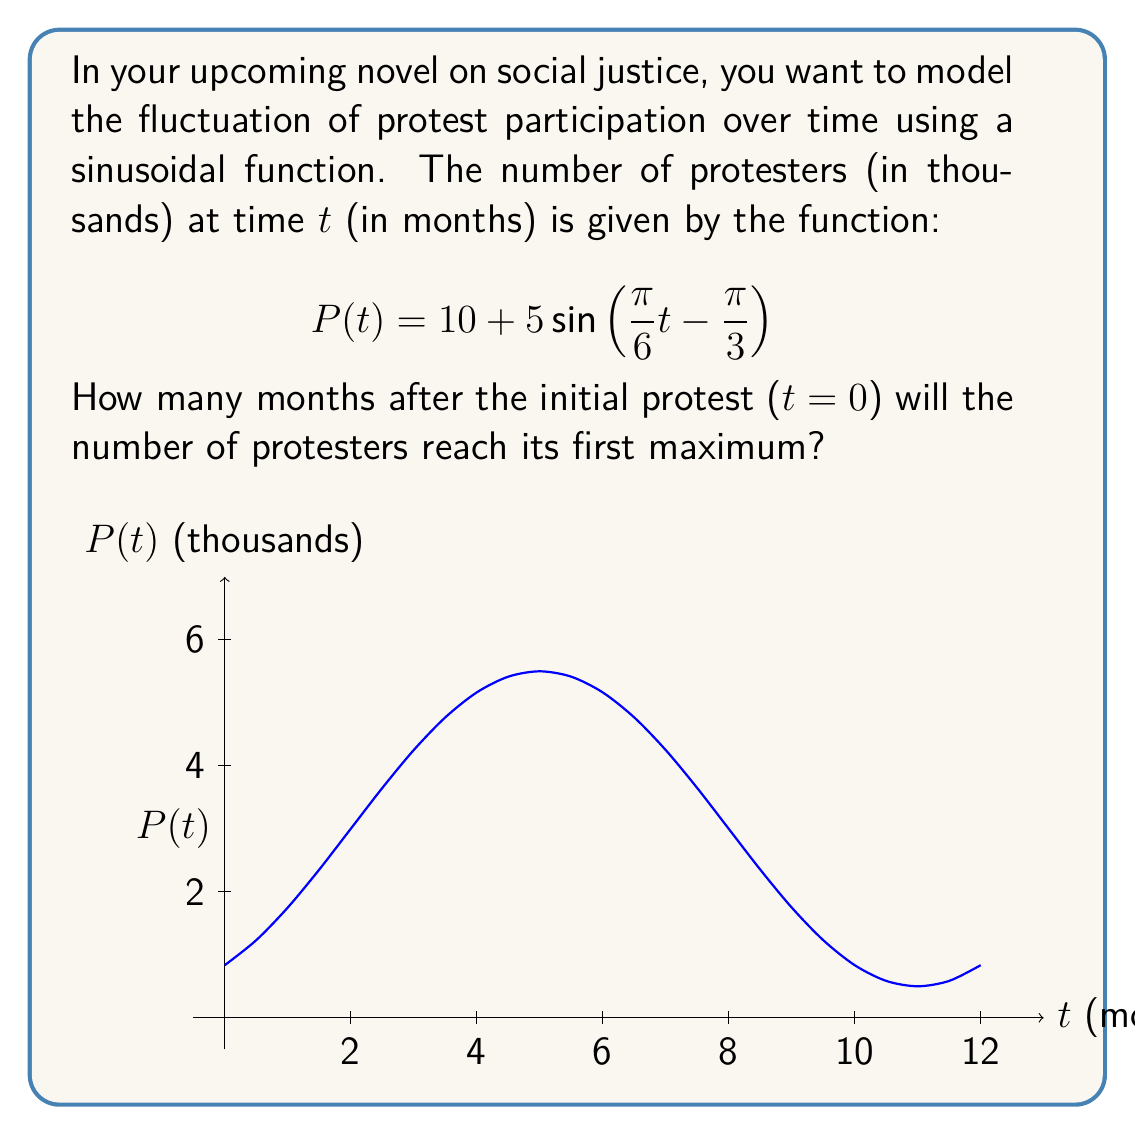Show me your answer to this math problem. To find when the number of protesters reaches its first maximum, we need to determine when the sine function within P(t) reaches its maximum value of 1. Let's approach this step-by-step:

1) The general form of a sine function is $A\sin(Bt - C) + D$, where B determines the period, C the phase shift, and D the vertical shift.

2) In our function, $B = \frac{\pi}{6}$, $C = \frac{\pi}{3}$, and $D = 10$.

3) The sine function reaches its maximum when the argument $(Bt - C)$ equals $\frac{\pi}{2}$. So we need to solve:

   $$\frac{\pi}{6}t - \frac{\pi}{3} = \frac{\pi}{2}$$

4) Add $\frac{\pi}{3}$ to both sides:

   $$\frac{\pi}{6}t = \frac{\pi}{2} + \frac{\pi}{3} = \frac{5\pi}{6}$$

5) Multiply both sides by $\frac{6}{\pi}$:

   $$t = \frac{6}{\pi} \cdot \frac{5\pi}{6} = 5$$

Therefore, the number of protesters will reach its first maximum 5 months after the initial protest.
Answer: 5 months 